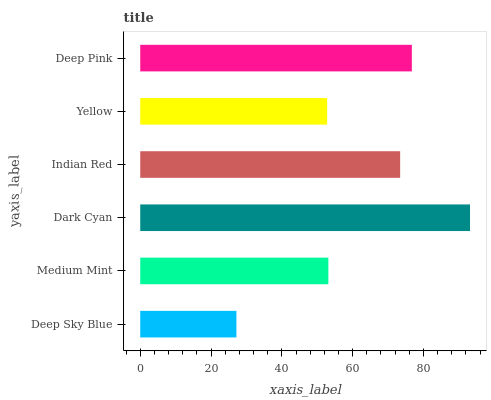Is Deep Sky Blue the minimum?
Answer yes or no. Yes. Is Dark Cyan the maximum?
Answer yes or no. Yes. Is Medium Mint the minimum?
Answer yes or no. No. Is Medium Mint the maximum?
Answer yes or no. No. Is Medium Mint greater than Deep Sky Blue?
Answer yes or no. Yes. Is Deep Sky Blue less than Medium Mint?
Answer yes or no. Yes. Is Deep Sky Blue greater than Medium Mint?
Answer yes or no. No. Is Medium Mint less than Deep Sky Blue?
Answer yes or no. No. Is Indian Red the high median?
Answer yes or no. Yes. Is Medium Mint the low median?
Answer yes or no. Yes. Is Medium Mint the high median?
Answer yes or no. No. Is Deep Pink the low median?
Answer yes or no. No. 